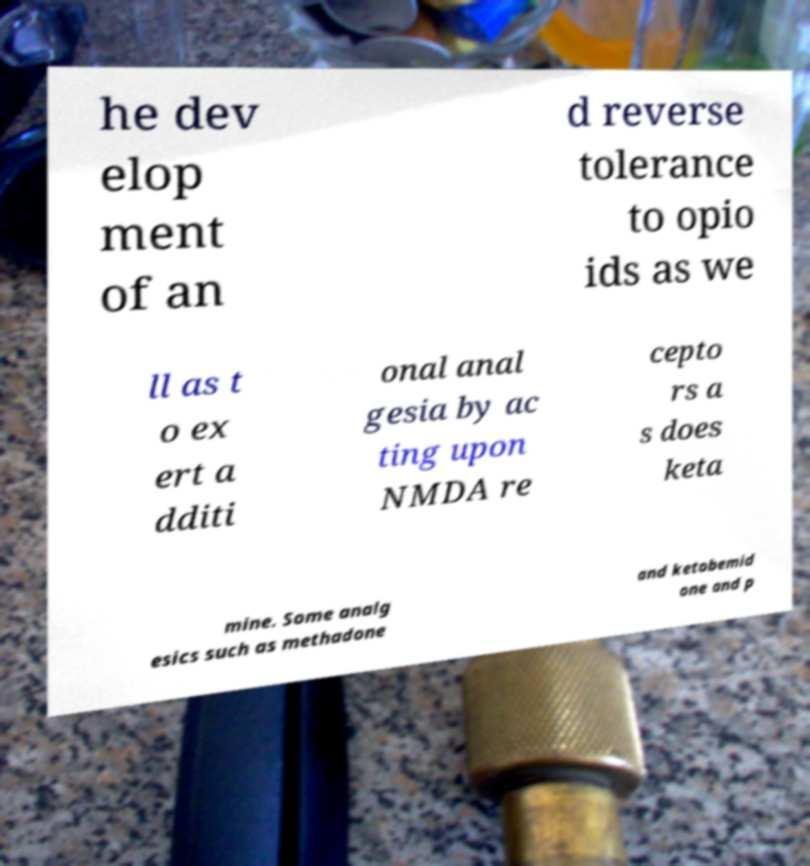For documentation purposes, I need the text within this image transcribed. Could you provide that? he dev elop ment of an d reverse tolerance to opio ids as we ll as t o ex ert a dditi onal anal gesia by ac ting upon NMDA re cepto rs a s does keta mine. Some analg esics such as methadone and ketobemid one and p 